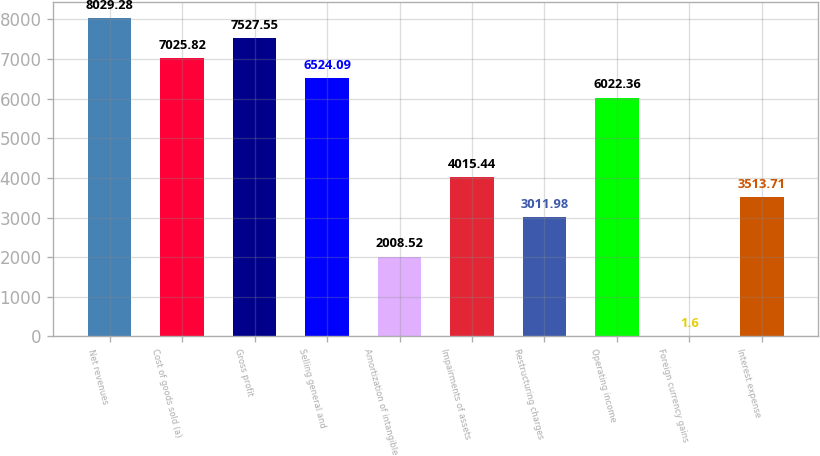<chart> <loc_0><loc_0><loc_500><loc_500><bar_chart><fcel>Net revenues<fcel>Cost of goods sold (a)<fcel>Gross profit<fcel>Selling general and<fcel>Amortization of intangible<fcel>Impairments of assets<fcel>Restructuring charges<fcel>Operating income<fcel>Foreign currency gains<fcel>Interest expense<nl><fcel>8029.28<fcel>7025.82<fcel>7527.55<fcel>6524.09<fcel>2008.52<fcel>4015.44<fcel>3011.98<fcel>6022.36<fcel>1.6<fcel>3513.71<nl></chart> 